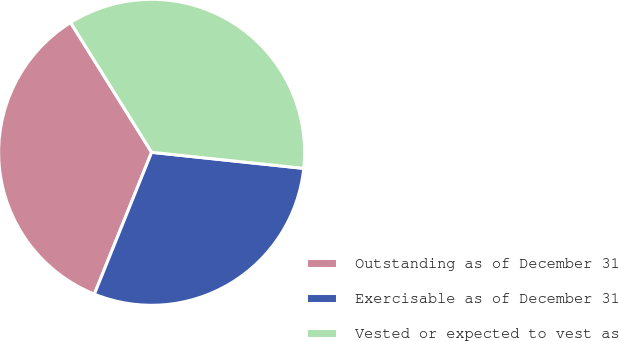Convert chart to OTSL. <chart><loc_0><loc_0><loc_500><loc_500><pie_chart><fcel>Outstanding as of December 31<fcel>Exercisable as of December 31<fcel>Vested or expected to vest as<nl><fcel>35.01%<fcel>29.43%<fcel>35.56%<nl></chart> 